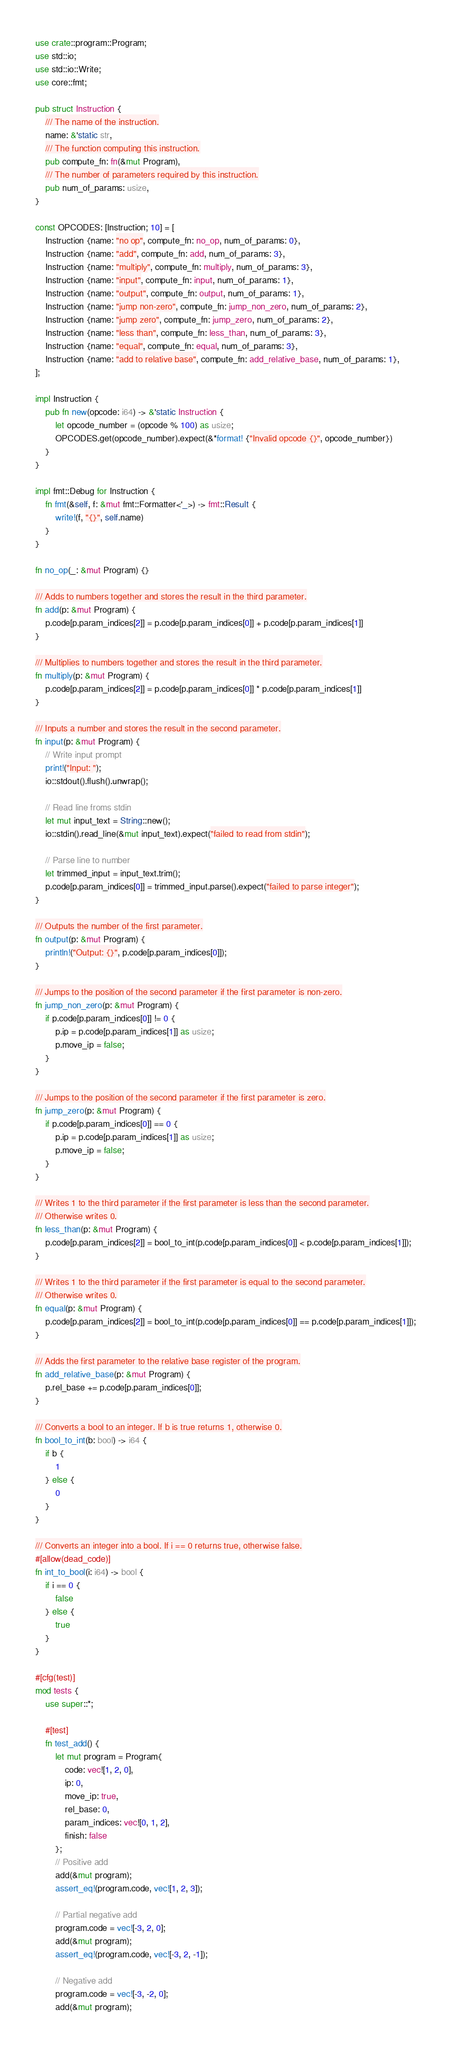Convert code to text. <code><loc_0><loc_0><loc_500><loc_500><_Rust_>use crate::program::Program;
use std::io;
use std::io::Write;
use core::fmt;

pub struct Instruction {
    /// The name of the instruction.
    name: &'static str,
    /// The function computing this instruction.
    pub compute_fn: fn(&mut Program),
    /// The number of parameters required by this instruction.
    pub num_of_params: usize,
}

const OPCODES: [Instruction; 10] = [
    Instruction {name: "no op", compute_fn: no_op, num_of_params: 0},
    Instruction {name: "add", compute_fn: add, num_of_params: 3},
    Instruction {name: "multiply", compute_fn: multiply, num_of_params: 3},
    Instruction {name: "input", compute_fn: input, num_of_params: 1},
    Instruction {name: "output", compute_fn: output, num_of_params: 1},
    Instruction {name: "jump non-zero", compute_fn: jump_non_zero, num_of_params: 2},
    Instruction {name: "jump zero", compute_fn: jump_zero, num_of_params: 2},
    Instruction {name: "less than", compute_fn: less_than, num_of_params: 3},
    Instruction {name: "equal", compute_fn: equal, num_of_params: 3},
    Instruction {name: "add to relative base", compute_fn: add_relative_base, num_of_params: 1},
];

impl Instruction {
    pub fn new(opcode: i64) -> &'static Instruction {
        let opcode_number = (opcode % 100) as usize;
        OPCODES.get(opcode_number).expect(&*format! {"Invalid opcode {}", opcode_number})
    }
}

impl fmt::Debug for Instruction {
    fn fmt(&self, f: &mut fmt::Formatter<'_>) -> fmt::Result {
        write!(f, "{}", self.name)
    }
}

fn no_op(_: &mut Program) {}

/// Adds to numbers together and stores the result in the third parameter.
fn add(p: &mut Program) {
    p.code[p.param_indices[2]] = p.code[p.param_indices[0]] + p.code[p.param_indices[1]]
}

/// Multiplies to numbers together and stores the result in the third parameter.
fn multiply(p: &mut Program) {
    p.code[p.param_indices[2]] = p.code[p.param_indices[0]] * p.code[p.param_indices[1]]
}

/// Inputs a number and stores the result in the second parameter.
fn input(p: &mut Program) {
    // Write input prompt
    print!("Input: ");
    io::stdout().flush().unwrap();

    // Read line froms stdin
    let mut input_text = String::new();
    io::stdin().read_line(&mut input_text).expect("failed to read from stdin");

    // Parse line to number
    let trimmed_input = input_text.trim();
    p.code[p.param_indices[0]] = trimmed_input.parse().expect("failed to parse integer");
}

/// Outputs the number of the first parameter.
fn output(p: &mut Program) {
    println!("Output: {}", p.code[p.param_indices[0]]);
}

/// Jumps to the position of the second parameter if the first parameter is non-zero.
fn jump_non_zero(p: &mut Program) {
    if p.code[p.param_indices[0]] != 0 {
        p.ip = p.code[p.param_indices[1]] as usize;
        p.move_ip = false;
    }
}

/// Jumps to the position of the second parameter if the first parameter is zero.
fn jump_zero(p: &mut Program) {
    if p.code[p.param_indices[0]] == 0 {
        p.ip = p.code[p.param_indices[1]] as usize;
        p.move_ip = false;
    }
}

/// Writes 1 to the third parameter if the first parameter is less than the second parameter.
/// Otherwise writes 0.
fn less_than(p: &mut Program) {
    p.code[p.param_indices[2]] = bool_to_int(p.code[p.param_indices[0]] < p.code[p.param_indices[1]]);
}

/// Writes 1 to the third parameter if the first parameter is equal to the second parameter.
/// Otherwise writes 0.
fn equal(p: &mut Program) {
    p.code[p.param_indices[2]] = bool_to_int(p.code[p.param_indices[0]] == p.code[p.param_indices[1]]);
}

/// Adds the first parameter to the relative base register of the program.
fn add_relative_base(p: &mut Program) {
    p.rel_base += p.code[p.param_indices[0]];
}

/// Converts a bool to an integer. If b is true returns 1, otherwise 0.
fn bool_to_int(b: bool) -> i64 {
    if b {
        1
    } else {
        0
    }
}

/// Converts an integer into a bool. If i == 0 returns true, otherwise false.
#[allow(dead_code)]
fn int_to_bool(i: i64) -> bool {
    if i == 0 {
        false
    } else {
        true
    }
}

#[cfg(test)]
mod tests {
    use super::*;

    #[test]
    fn test_add() {
        let mut program = Program{
            code: vec![1, 2, 0],
            ip: 0,
            move_ip: true,
            rel_base: 0,
            param_indices: vec![0, 1, 2],
            finish: false
        };
        // Positive add
        add(&mut program);
        assert_eq!(program.code, vec![1, 2, 3]);

        // Partial negative add
        program.code = vec![-3, 2, 0];
        add(&mut program);
        assert_eq!(program.code, vec![-3, 2, -1]);

        // Negative add
        program.code = vec![-3, -2, 0];
        add(&mut program);</code> 